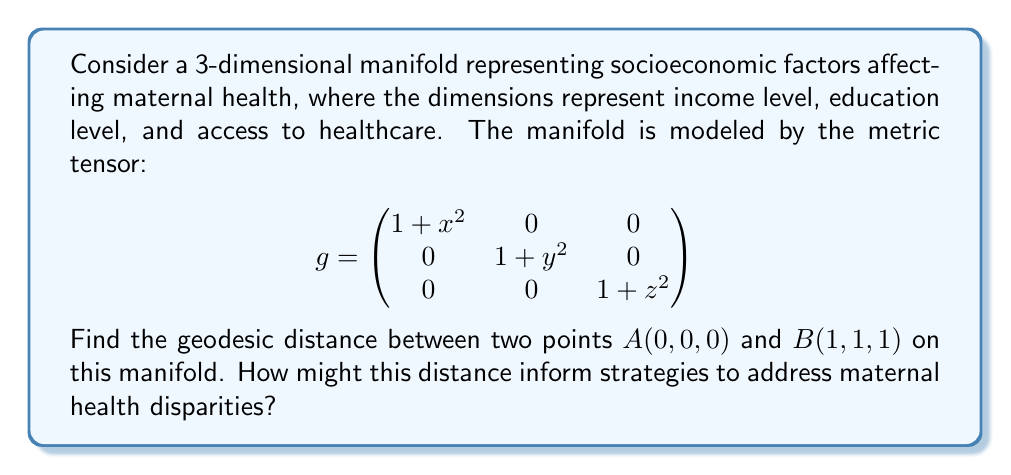Teach me how to tackle this problem. To find the geodesic distance between two points on a manifold, we need to solve the geodesic equation and then calculate the length of the resulting curve. However, for this particular metric, we can use a simpler approach.

1) The metric tensor is diagonal, which means the coordinate curves are orthogonal. In this case, the geodesic between two points is a straight line in the manifold's coordinate system.

2) The geodesic distance is given by the integral:

   $$d = \int_0^1 \sqrt{g_{11}(\dot{x})^2 + g_{22}(\dot{y})^2 + g_{33}(\dot{z})^2} dt$$

   where $\dot{x}, \dot{y}, \dot{z}$ are the derivatives with respect to the parameter $t$.

3) For a straight line from $(0,0,0)$ to $(1,1,1)$, we have $x(t) = y(t) = z(t) = t$, so $\dot{x} = \dot{y} = \dot{z} = 1$.

4) Substituting into the integral:

   $$d = \int_0^1 \sqrt{(1+t^2) + (1+t^2) + (1+t^2)} dt = \int_0^1 \sqrt{3+3t^2} dt$$

5) This integral can be solved using the substitution $u = \sqrt{3+3t^2}$:

   $$d = \frac{1}{\sqrt{3}} \int_{\sqrt{3}}^{\sqrt{6}} u du = \frac{1}{\sqrt{3}} [\frac{1}{2}u^2]_{\sqrt{3}}^{\sqrt{6}}$$

6) Evaluating:

   $$d = \frac{1}{\sqrt{3}} (\frac{1}{2}(6) - \frac{1}{2}(3)) = \frac{\sqrt{3}}{2}$$

This distance represents the "cost" of moving from one socioeconomic state to another in terms of maternal health outcomes. A larger distance indicates a more significant disparity and potentially more resources needed to address it. Social entrepreneurs could use this information to prioritize interventions that target the factors contributing most to this distance, potentially focusing on improving income levels, education, or healthcare access depending on which dimension contributes most to the geodesic distance.
Answer: The geodesic distance between points $A(0,0,0)$ and $B(1,1,1)$ on the given manifold is $\frac{\sqrt{3}}{2}$. 